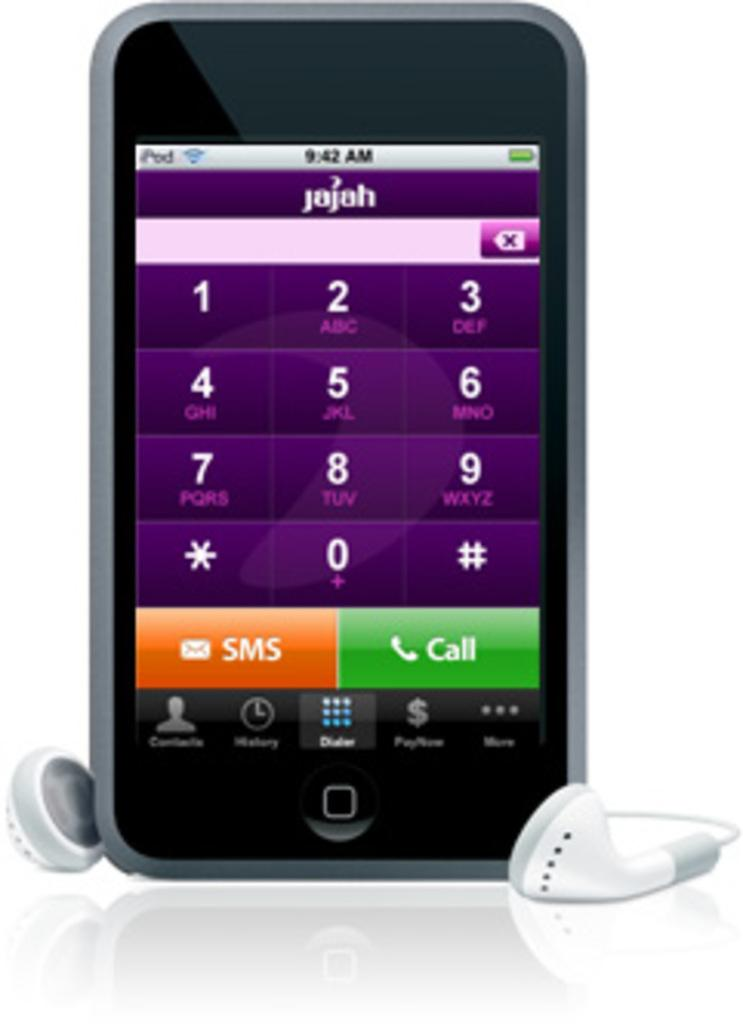<image>
Share a concise interpretation of the image provided. A Jajah phone opened up to SMS and Call buttons. 